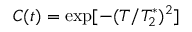<formula> <loc_0><loc_0><loc_500><loc_500>C ( t ) = \exp [ - ( T / T _ { 2 } ^ { * } ) ^ { 2 } ]</formula> 